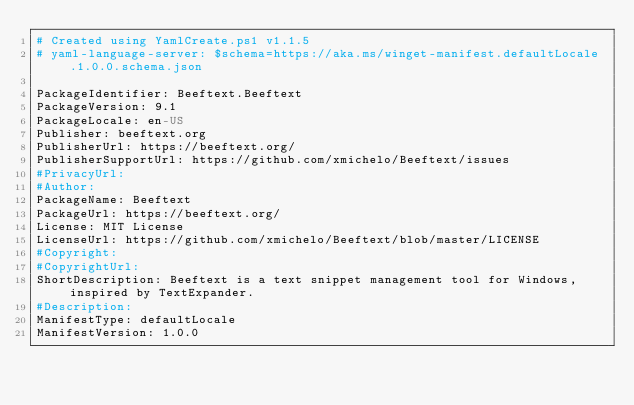Convert code to text. <code><loc_0><loc_0><loc_500><loc_500><_YAML_># Created using YamlCreate.ps1 v1.1.5
# yaml-language-server: $schema=https://aka.ms/winget-manifest.defaultLocale.1.0.0.schema.json

PackageIdentifier: Beeftext.Beeftext
PackageVersion: 9.1
PackageLocale: en-US
Publisher: beeftext.org
PublisherUrl: https://beeftext.org/
PublisherSupportUrl: https://github.com/xmichelo/Beeftext/issues
#PrivacyUrl: 
#Author: 
PackageName: Beeftext
PackageUrl: https://beeftext.org/
License: MIT License
LicenseUrl: https://github.com/xmichelo/Beeftext/blob/master/LICENSE
#Copyright: 
#CopyrightUrl: 
ShortDescription: Beeftext is a text snippet management tool for Windows, inspired by TextExpander.
#Description: 
ManifestType: defaultLocale
ManifestVersion: 1.0.0

</code> 